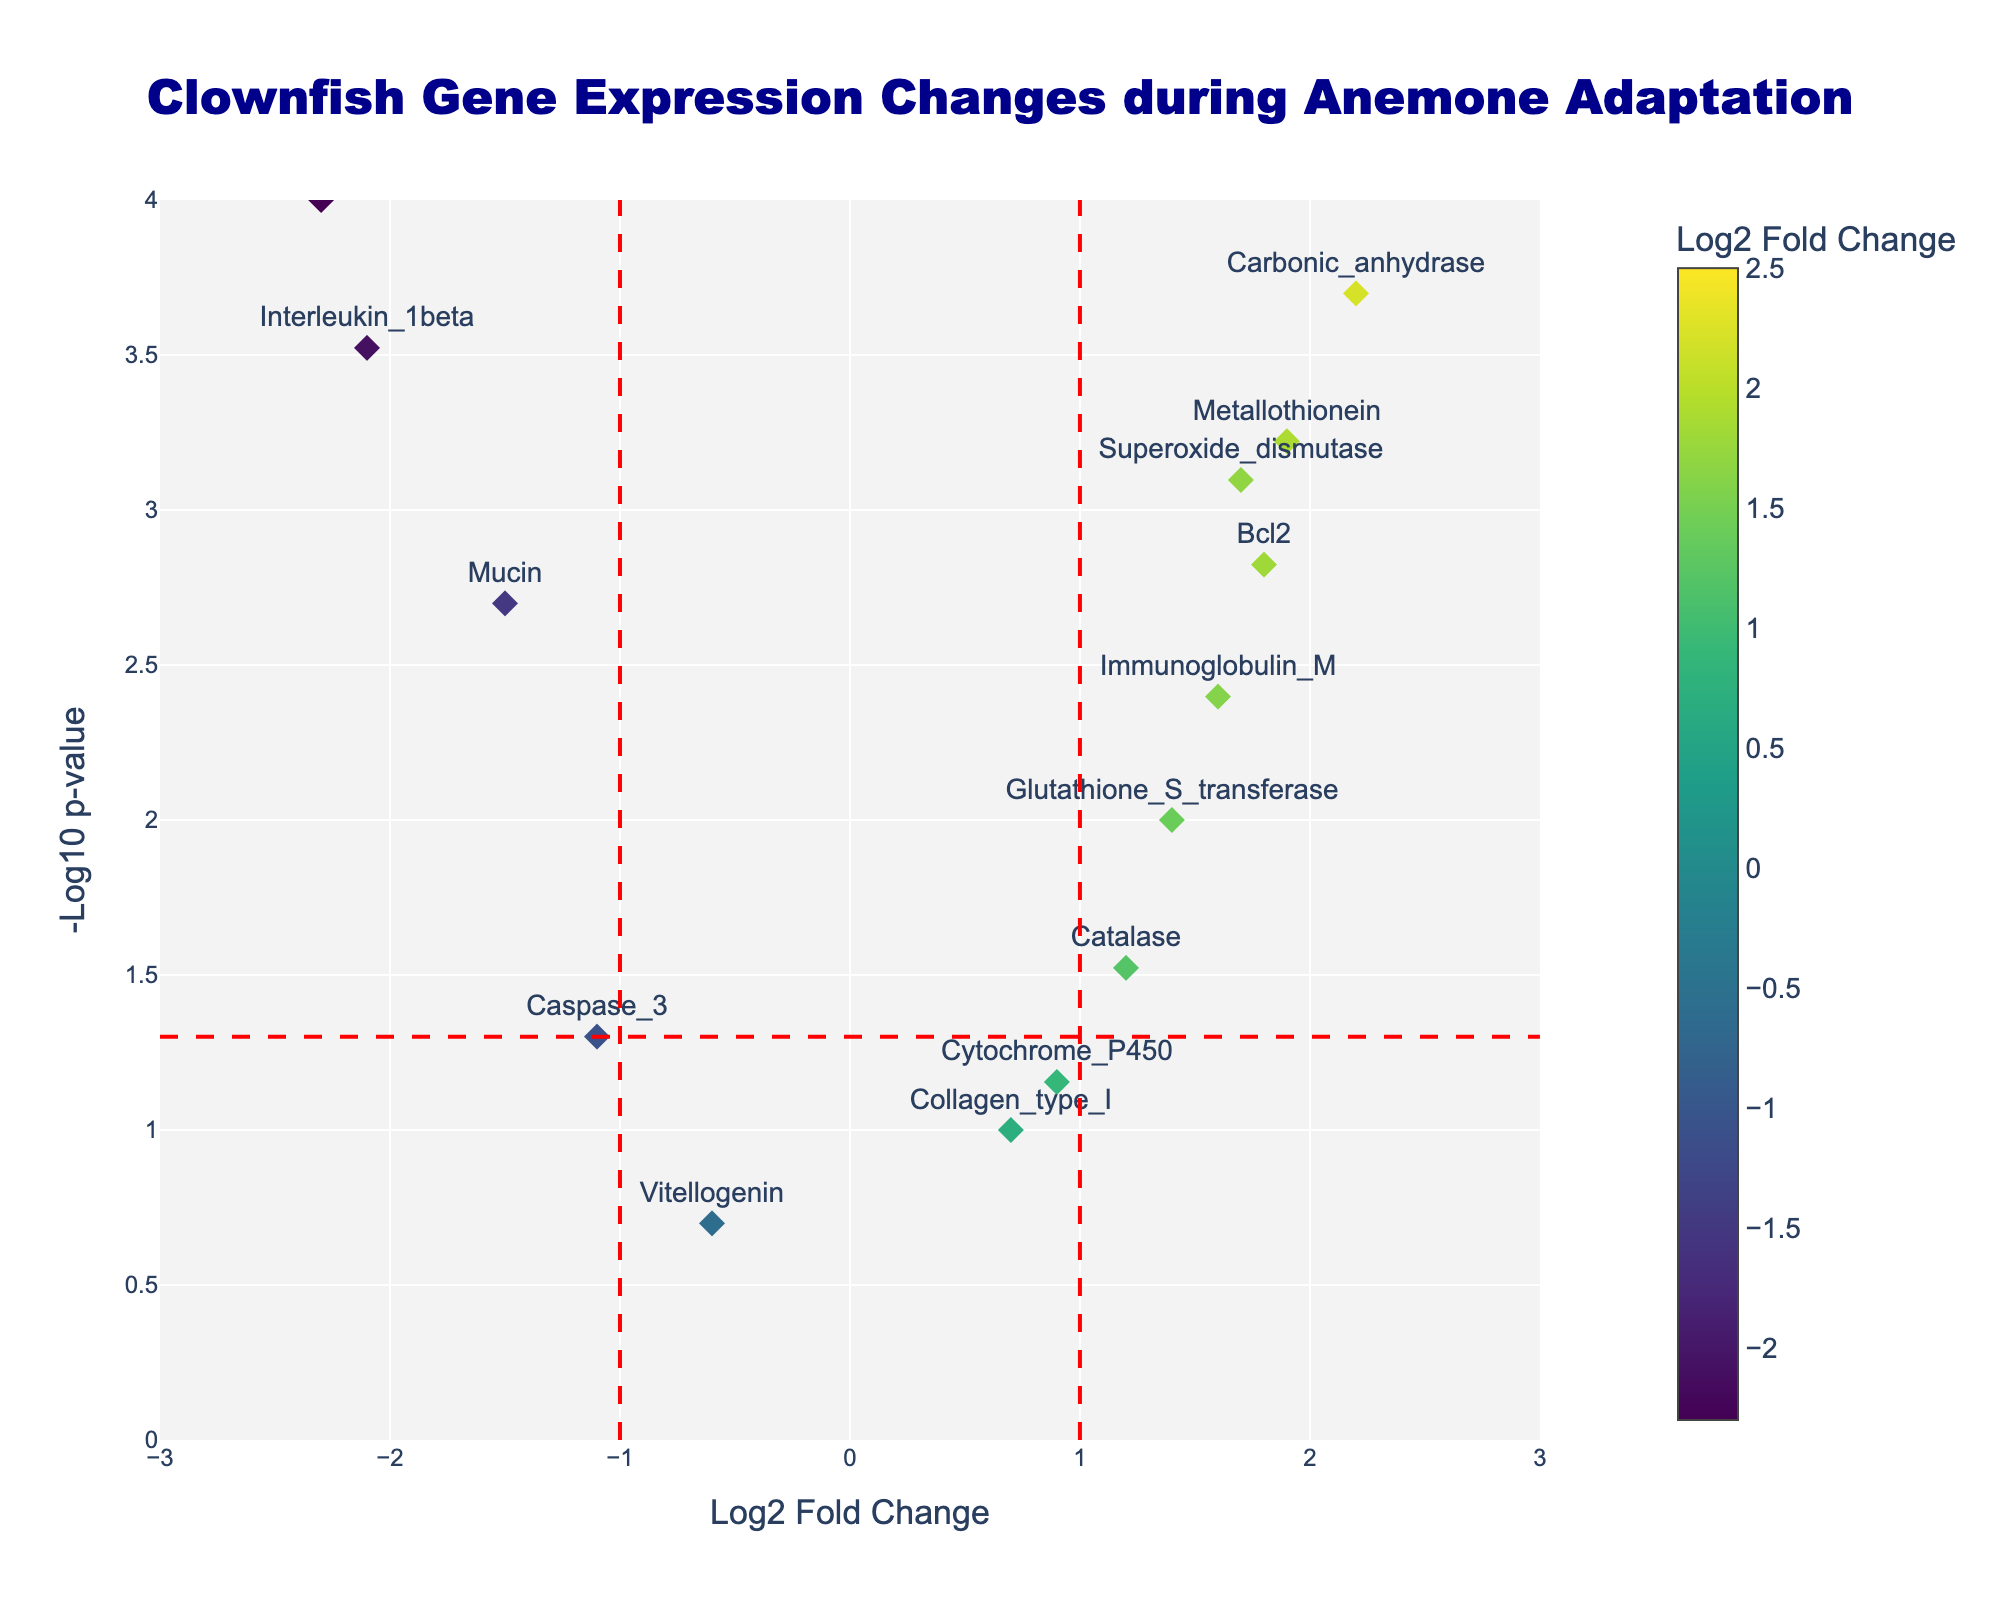what is the title of the figure? The title of the figure appears at the top and states what the plot is about. Here, the title is "Clownfish Gene Expression Changes during Anemone Adaptation". By reading directly from the figure, we can identify the title.
Answer: Clownfish Gene Expression Changes during Anemone Adaptation How many genes have a log2 fold change greater than 1? The plot displays data points along the x-axis with their log2 fold change values. By counting the data points to the right of the vertical line at x=1, we can determine how many genes have a log2 fold change greater than 1. Here, there are 4 genes with a log2 fold change greater than 1.
Answer: 4 Which gene has the lowest p-value? To find the gene with the lowest p-value, look for the highest point on the y-axis since -log10(p-value) increases as p-value decreases. For this plot, the highest point corresponds to "NaKATPase".
Answer: NaKATPase Is "Interleukin_1beta" upregulated or downregulated? To determine if "Interleukin_1beta" is upregulated or downregulated, observe its log2 fold change value. A negative log2 fold change indicates downregulation. From the plot, "Interleukin_1beta" has a negative log2 fold change, so it is downregulated.
Answer: Downregulated Which genes are marked close to the x=0 vertical line? Genes near the vertical line at x=0 have log2 fold change values close to zero, indicating little or no change in expression. From the plot, "Cytochrome_P450" and "Collagen_type_I" are close to this line.
Answer: Cytochrome_P450 and Collagen_type_I What is the log2 fold change value for "Hsp70"? Find the "Hsp70" point on the plot and note its x-axis value, which represents the log2 fold change. "Hsp70" is at -2.3 on the x-axis.
Answer: -2.3 Which gene has the highest log2 fold change? To identify the gene with the highest log2 fold change, find the rightmost data point on the x-axis. The gene "NaKATPase" has the highest value at 2.5.
Answer: NaKATPase Which genes are statistically significant based on the p-value threshold marked by a horizontal line at y=-log10(0.05)? Genes above this horizontal line are statistically significant because they have p-values lower than 0.05. Looking at the plot, the genes above this line are "Hsp70", "Bcl2", "NaKATPase", "Mucin", "Superoxide_dismutase", "Interleukin_1beta", "Carbonic_anhydrase", "Metallothionein", and "Immunoglobulin_M".
Answer: Hsp70, Bcl2, NaKATPase, Mucin, Superoxide_dismutase, Interleukin_1beta, Carbonic_anhydrase, Metallothionein, Immunoglobulin_M 